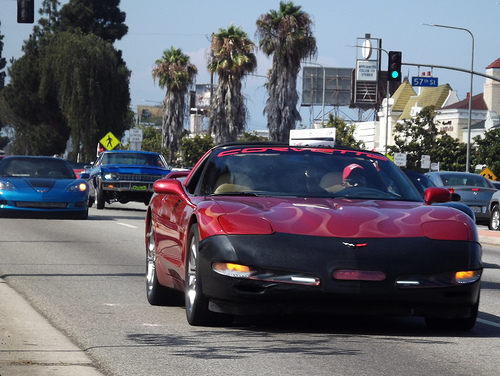<image>
Can you confirm if the sky is behind the tree? Yes. From this viewpoint, the sky is positioned behind the tree, with the tree partially or fully occluding the sky. Where is the car in relation to the car? Is it in front of the car? Yes. The car is positioned in front of the car, appearing closer to the camera viewpoint. 